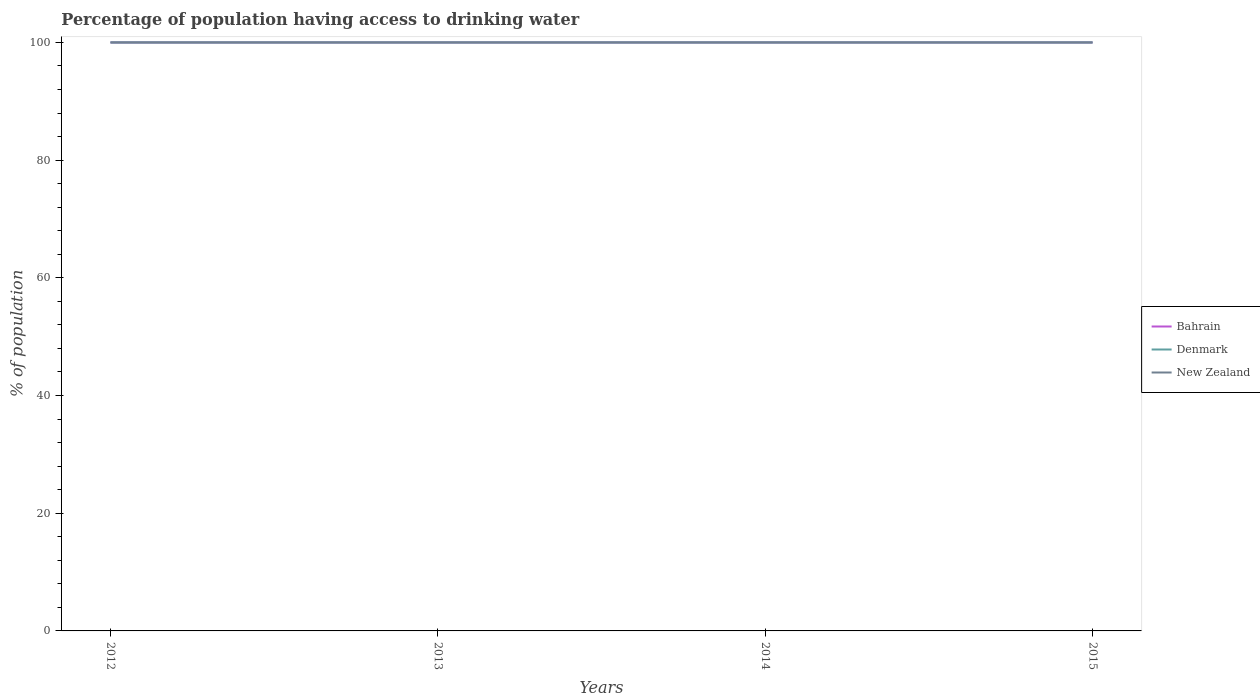Does the line corresponding to Bahrain intersect with the line corresponding to Denmark?
Offer a terse response. Yes. Is the number of lines equal to the number of legend labels?
Your answer should be compact. Yes. Across all years, what is the maximum percentage of population having access to drinking water in Bahrain?
Keep it short and to the point. 100. Is the percentage of population having access to drinking water in Denmark strictly greater than the percentage of population having access to drinking water in New Zealand over the years?
Offer a terse response. No. How many lines are there?
Your response must be concise. 3. How many years are there in the graph?
Keep it short and to the point. 4. Are the values on the major ticks of Y-axis written in scientific E-notation?
Provide a succinct answer. No. Does the graph contain any zero values?
Offer a very short reply. No. Does the graph contain grids?
Provide a succinct answer. No. Where does the legend appear in the graph?
Make the answer very short. Center right. What is the title of the graph?
Provide a succinct answer. Percentage of population having access to drinking water. What is the label or title of the Y-axis?
Give a very brief answer. % of population. What is the % of population of Bahrain in 2012?
Keep it short and to the point. 100. What is the % of population of Denmark in 2012?
Make the answer very short. 100. What is the % of population in Bahrain in 2013?
Offer a terse response. 100. What is the % of population of Denmark in 2013?
Give a very brief answer. 100. What is the % of population in Bahrain in 2014?
Offer a very short reply. 100. What is the % of population of Bahrain in 2015?
Ensure brevity in your answer.  100. Across all years, what is the maximum % of population of Bahrain?
Provide a short and direct response. 100. Across all years, what is the maximum % of population in Denmark?
Give a very brief answer. 100. Across all years, what is the maximum % of population in New Zealand?
Make the answer very short. 100. Across all years, what is the minimum % of population of Bahrain?
Your answer should be very brief. 100. Across all years, what is the minimum % of population of Denmark?
Provide a short and direct response. 100. What is the total % of population in Bahrain in the graph?
Provide a short and direct response. 400. What is the difference between the % of population of Denmark in 2012 and that in 2013?
Offer a very short reply. 0. What is the difference between the % of population of New Zealand in 2012 and that in 2013?
Your answer should be very brief. 0. What is the difference between the % of population of New Zealand in 2012 and that in 2014?
Provide a short and direct response. 0. What is the difference between the % of population of Bahrain in 2012 and that in 2015?
Your response must be concise. 0. What is the difference between the % of population of Bahrain in 2013 and that in 2015?
Give a very brief answer. 0. What is the difference between the % of population in Denmark in 2013 and that in 2015?
Your answer should be compact. 0. What is the difference between the % of population of Denmark in 2014 and that in 2015?
Offer a terse response. 0. What is the difference between the % of population in New Zealand in 2014 and that in 2015?
Ensure brevity in your answer.  0. What is the difference between the % of population of Denmark in 2012 and the % of population of New Zealand in 2013?
Give a very brief answer. 0. What is the difference between the % of population of Bahrain in 2012 and the % of population of Denmark in 2014?
Give a very brief answer. 0. What is the difference between the % of population of Bahrain in 2012 and the % of population of New Zealand in 2014?
Ensure brevity in your answer.  0. What is the difference between the % of population in Denmark in 2012 and the % of population in New Zealand in 2014?
Give a very brief answer. 0. What is the difference between the % of population of Bahrain in 2012 and the % of population of New Zealand in 2015?
Provide a succinct answer. 0. What is the difference between the % of population in Denmark in 2013 and the % of population in New Zealand in 2014?
Keep it short and to the point. 0. What is the difference between the % of population of Bahrain in 2013 and the % of population of Denmark in 2015?
Your answer should be very brief. 0. What is the difference between the % of population of Denmark in 2013 and the % of population of New Zealand in 2015?
Provide a succinct answer. 0. What is the difference between the % of population of Bahrain in 2014 and the % of population of New Zealand in 2015?
Offer a very short reply. 0. What is the average % of population of Bahrain per year?
Give a very brief answer. 100. What is the average % of population in New Zealand per year?
Ensure brevity in your answer.  100. In the year 2012, what is the difference between the % of population in Bahrain and % of population in New Zealand?
Your answer should be very brief. 0. In the year 2012, what is the difference between the % of population of Denmark and % of population of New Zealand?
Your answer should be very brief. 0. In the year 2013, what is the difference between the % of population in Denmark and % of population in New Zealand?
Keep it short and to the point. 0. In the year 2014, what is the difference between the % of population in Bahrain and % of population in Denmark?
Provide a succinct answer. 0. In the year 2015, what is the difference between the % of population of Bahrain and % of population of Denmark?
Provide a succinct answer. 0. What is the ratio of the % of population in Denmark in 2012 to that in 2013?
Offer a very short reply. 1. What is the ratio of the % of population of Bahrain in 2012 to that in 2014?
Ensure brevity in your answer.  1. What is the ratio of the % of population of Denmark in 2012 to that in 2014?
Your answer should be compact. 1. What is the ratio of the % of population in Bahrain in 2012 to that in 2015?
Your answer should be compact. 1. What is the ratio of the % of population of New Zealand in 2012 to that in 2015?
Make the answer very short. 1. What is the ratio of the % of population in Denmark in 2013 to that in 2014?
Your answer should be very brief. 1. What is the ratio of the % of population of Bahrain in 2013 to that in 2015?
Ensure brevity in your answer.  1. What is the ratio of the % of population of Denmark in 2013 to that in 2015?
Provide a succinct answer. 1. What is the ratio of the % of population of Bahrain in 2014 to that in 2015?
Give a very brief answer. 1. What is the ratio of the % of population of New Zealand in 2014 to that in 2015?
Give a very brief answer. 1. What is the difference between the highest and the second highest % of population in Bahrain?
Keep it short and to the point. 0. What is the difference between the highest and the second highest % of population in New Zealand?
Ensure brevity in your answer.  0. What is the difference between the highest and the lowest % of population of Denmark?
Keep it short and to the point. 0. 